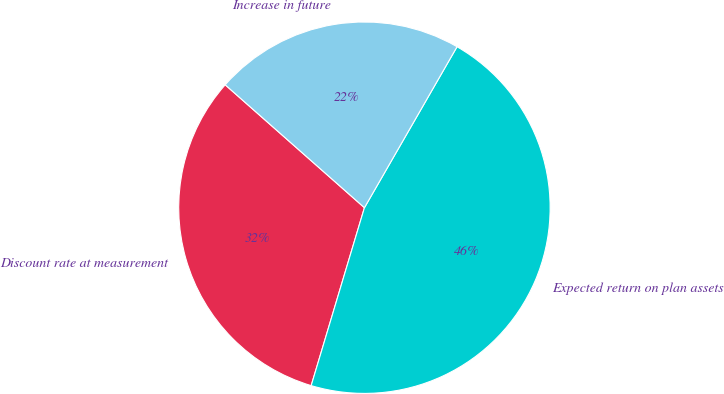<chart> <loc_0><loc_0><loc_500><loc_500><pie_chart><fcel>Discount rate at measurement<fcel>Expected return on plan assets<fcel>Increase in future<nl><fcel>31.88%<fcel>46.32%<fcel>21.8%<nl></chart> 